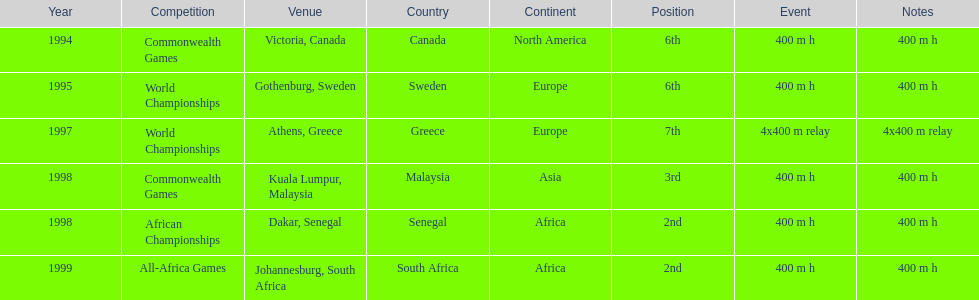What venue came before gothenburg, sweden? Victoria, Canada. 